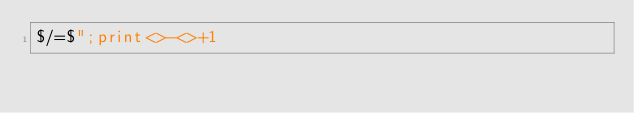<code> <loc_0><loc_0><loc_500><loc_500><_Perl_>$/=$";print<>-<>+1</code> 